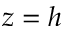Convert formula to latex. <formula><loc_0><loc_0><loc_500><loc_500>z = h</formula> 